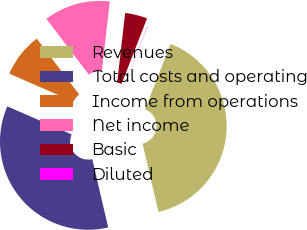Convert chart to OTSL. <chart><loc_0><loc_0><loc_500><loc_500><pie_chart><fcel>Revenues<fcel>Total costs and operating<fcel>Income from operations<fcel>Net income<fcel>Basic<fcel>Diluted<nl><fcel>40.41%<fcel>35.18%<fcel>8.12%<fcel>12.16%<fcel>4.08%<fcel>0.05%<nl></chart> 